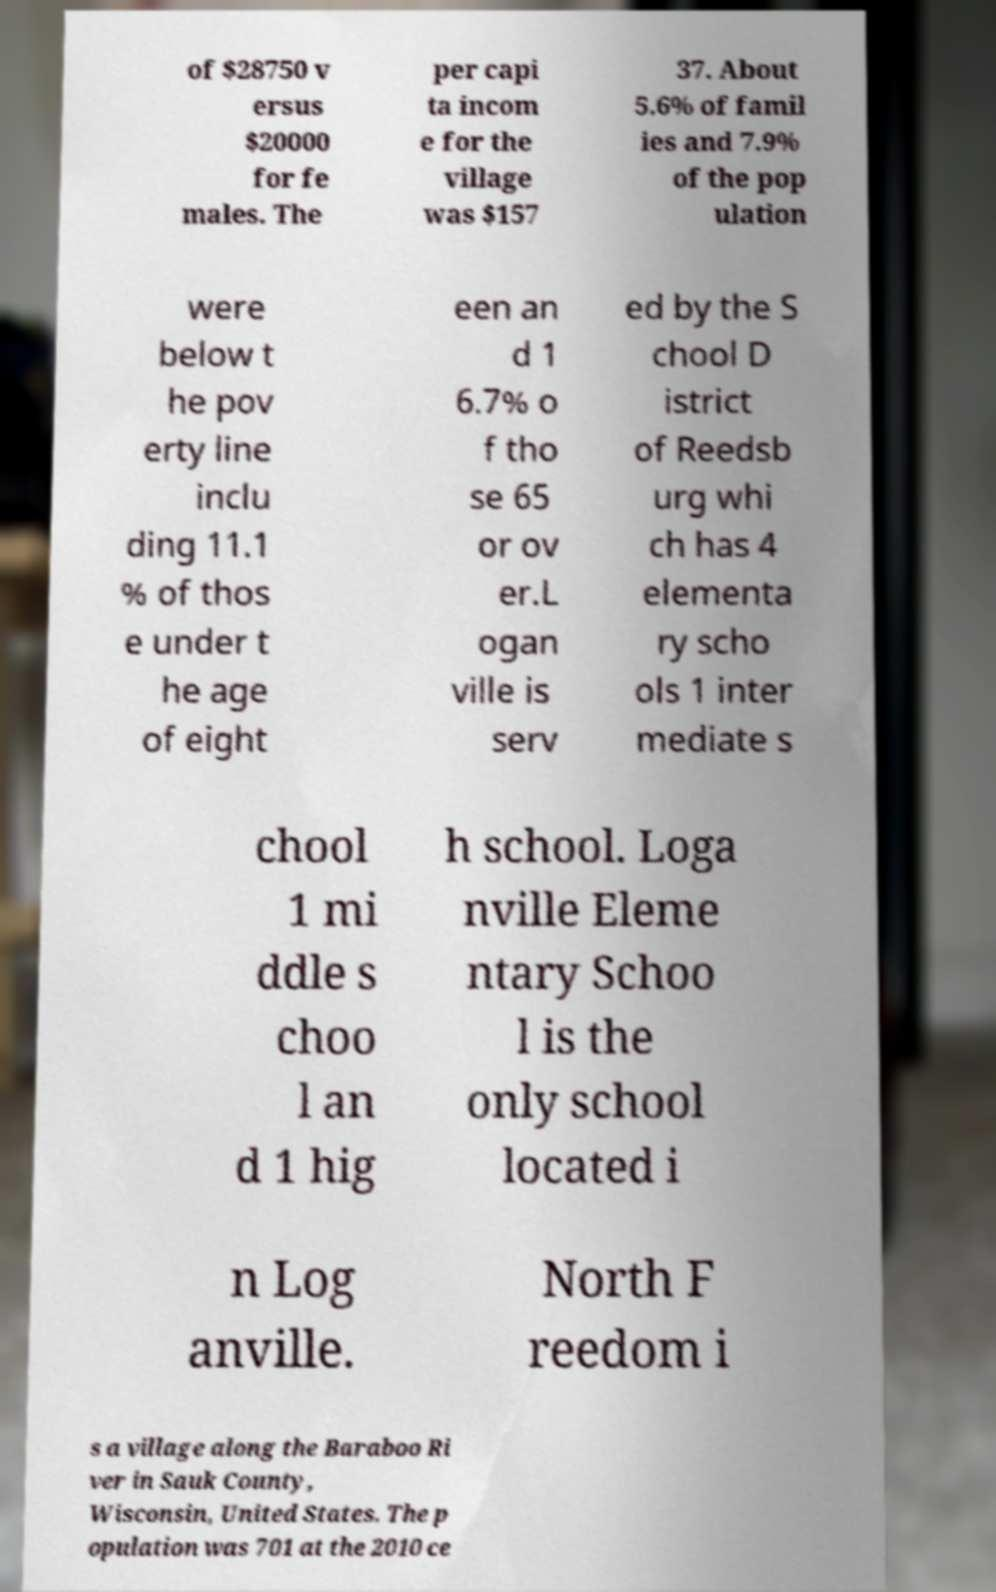Could you extract and type out the text from this image? of $28750 v ersus $20000 for fe males. The per capi ta incom e for the village was $157 37. About 5.6% of famil ies and 7.9% of the pop ulation were below t he pov erty line inclu ding 11.1 % of thos e under t he age of eight een an d 1 6.7% o f tho se 65 or ov er.L ogan ville is serv ed by the S chool D istrict of Reedsb urg whi ch has 4 elementa ry scho ols 1 inter mediate s chool 1 mi ddle s choo l an d 1 hig h school. Loga nville Eleme ntary Schoo l is the only school located i n Log anville. North F reedom i s a village along the Baraboo Ri ver in Sauk County, Wisconsin, United States. The p opulation was 701 at the 2010 ce 